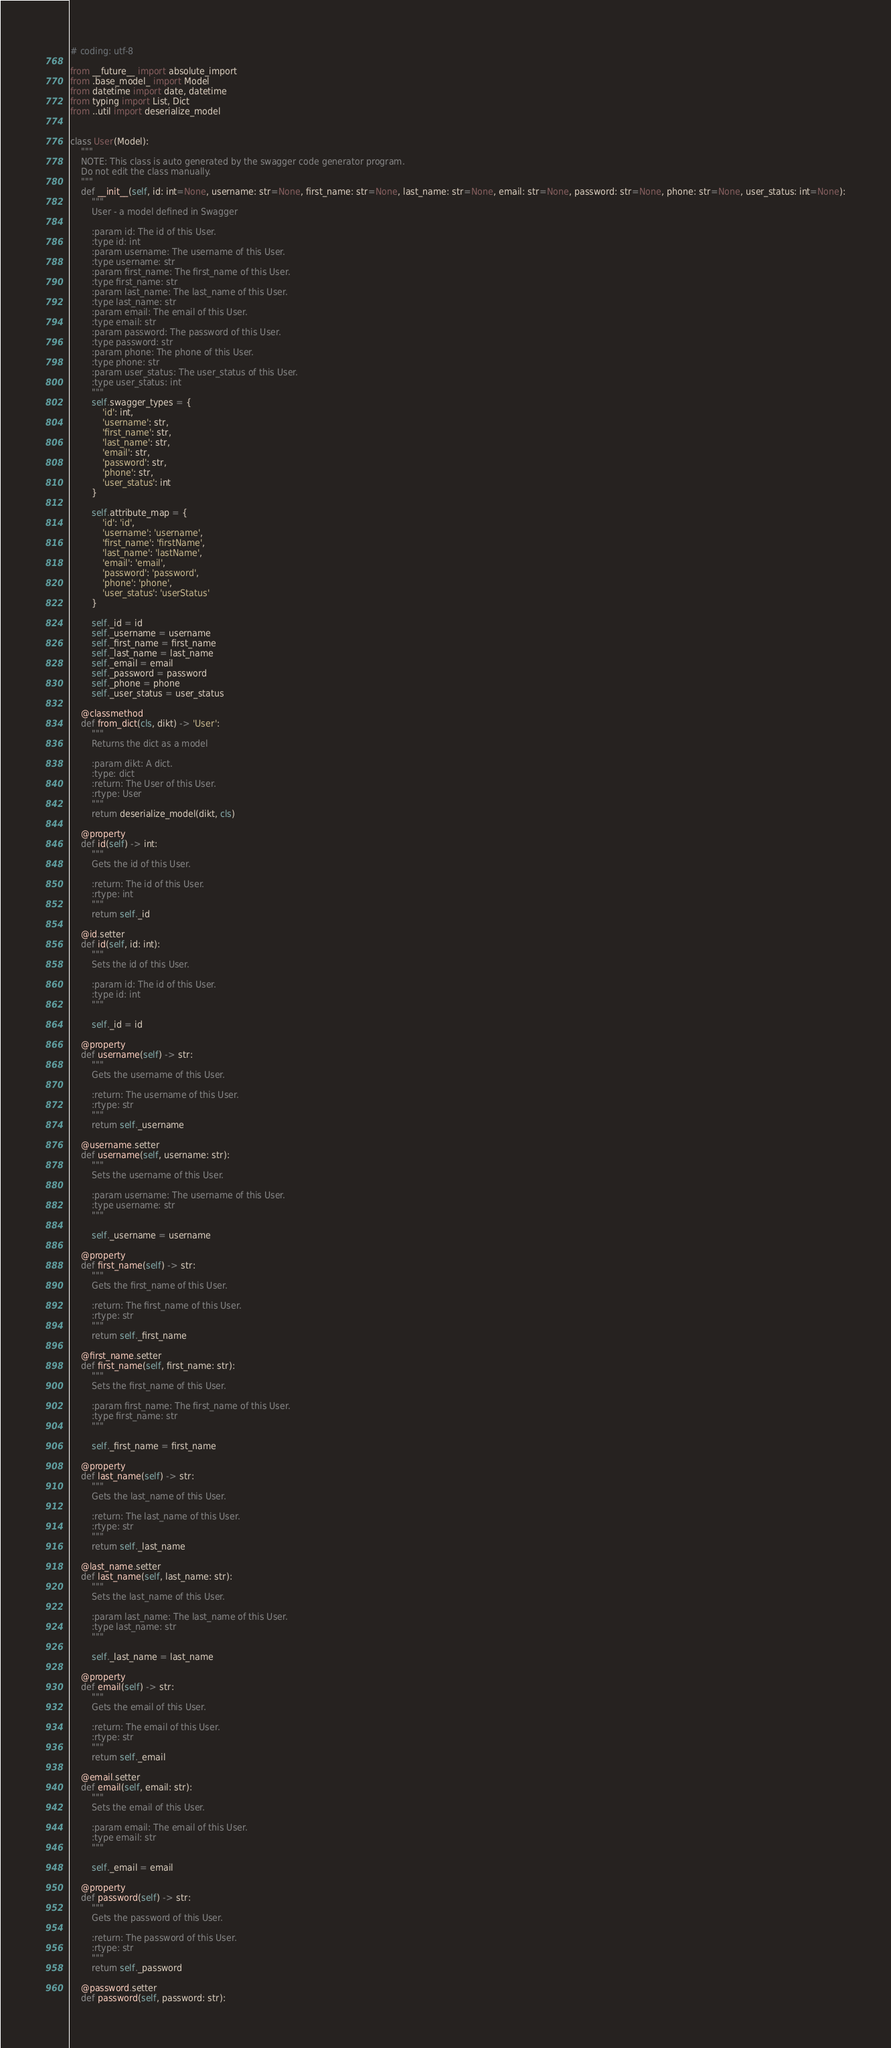<code> <loc_0><loc_0><loc_500><loc_500><_Python_># coding: utf-8

from __future__ import absolute_import
from .base_model_ import Model
from datetime import date, datetime
from typing import List, Dict
from ..util import deserialize_model


class User(Model):
    """
    NOTE: This class is auto generated by the swagger code generator program.
    Do not edit the class manually.
    """
    def __init__(self, id: int=None, username: str=None, first_name: str=None, last_name: str=None, email: str=None, password: str=None, phone: str=None, user_status: int=None):
        """
        User - a model defined in Swagger

        :param id: The id of this User.
        :type id: int
        :param username: The username of this User.
        :type username: str
        :param first_name: The first_name of this User.
        :type first_name: str
        :param last_name: The last_name of this User.
        :type last_name: str
        :param email: The email of this User.
        :type email: str
        :param password: The password of this User.
        :type password: str
        :param phone: The phone of this User.
        :type phone: str
        :param user_status: The user_status of this User.
        :type user_status: int
        """
        self.swagger_types = {
            'id': int,
            'username': str,
            'first_name': str,
            'last_name': str,
            'email': str,
            'password': str,
            'phone': str,
            'user_status': int
        }

        self.attribute_map = {
            'id': 'id',
            'username': 'username',
            'first_name': 'firstName',
            'last_name': 'lastName',
            'email': 'email',
            'password': 'password',
            'phone': 'phone',
            'user_status': 'userStatus'
        }

        self._id = id
        self._username = username
        self._first_name = first_name
        self._last_name = last_name
        self._email = email
        self._password = password
        self._phone = phone
        self._user_status = user_status

    @classmethod
    def from_dict(cls, dikt) -> 'User':
        """
        Returns the dict as a model

        :param dikt: A dict.
        :type: dict
        :return: The User of this User.
        :rtype: User
        """
        return deserialize_model(dikt, cls)

    @property
    def id(self) -> int:
        """
        Gets the id of this User.

        :return: The id of this User.
        :rtype: int
        """
        return self._id

    @id.setter
    def id(self, id: int):
        """
        Sets the id of this User.

        :param id: The id of this User.
        :type id: int
        """

        self._id = id

    @property
    def username(self) -> str:
        """
        Gets the username of this User.

        :return: The username of this User.
        :rtype: str
        """
        return self._username

    @username.setter
    def username(self, username: str):
        """
        Sets the username of this User.

        :param username: The username of this User.
        :type username: str
        """

        self._username = username

    @property
    def first_name(self) -> str:
        """
        Gets the first_name of this User.

        :return: The first_name of this User.
        :rtype: str
        """
        return self._first_name

    @first_name.setter
    def first_name(self, first_name: str):
        """
        Sets the first_name of this User.

        :param first_name: The first_name of this User.
        :type first_name: str
        """

        self._first_name = first_name

    @property
    def last_name(self) -> str:
        """
        Gets the last_name of this User.

        :return: The last_name of this User.
        :rtype: str
        """
        return self._last_name

    @last_name.setter
    def last_name(self, last_name: str):
        """
        Sets the last_name of this User.

        :param last_name: The last_name of this User.
        :type last_name: str
        """

        self._last_name = last_name

    @property
    def email(self) -> str:
        """
        Gets the email of this User.

        :return: The email of this User.
        :rtype: str
        """
        return self._email

    @email.setter
    def email(self, email: str):
        """
        Sets the email of this User.

        :param email: The email of this User.
        :type email: str
        """

        self._email = email

    @property
    def password(self) -> str:
        """
        Gets the password of this User.

        :return: The password of this User.
        :rtype: str
        """
        return self._password

    @password.setter
    def password(self, password: str):</code> 